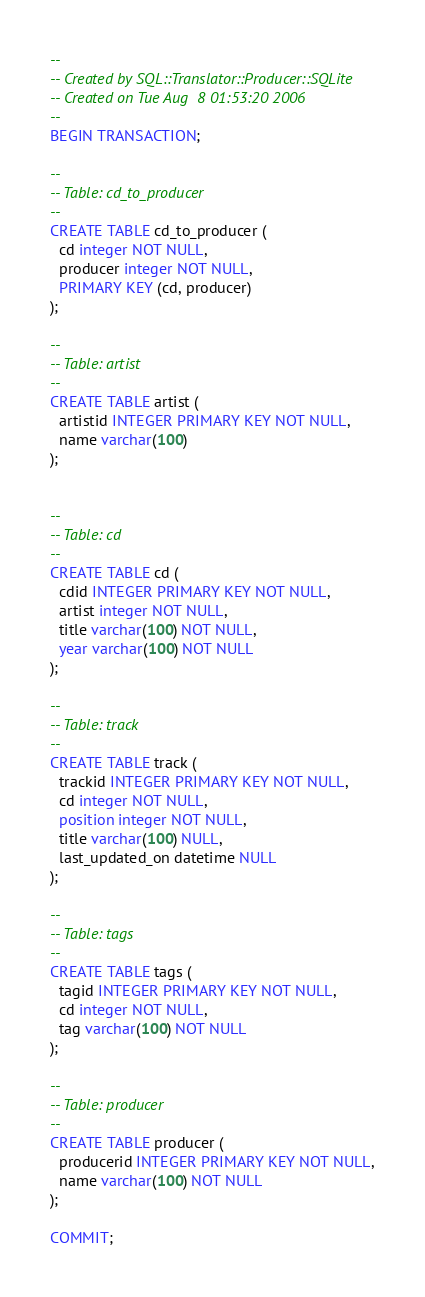<code> <loc_0><loc_0><loc_500><loc_500><_SQL_>-- 
-- Created by SQL::Translator::Producer::SQLite
-- Created on Tue Aug  8 01:53:20 2006
-- 
BEGIN TRANSACTION;

--
-- Table: cd_to_producer
--
CREATE TABLE cd_to_producer (
  cd integer NOT NULL,
  producer integer NOT NULL,
  PRIMARY KEY (cd, producer)
);

--
-- Table: artist
--
CREATE TABLE artist (
  artistid INTEGER PRIMARY KEY NOT NULL,
  name varchar(100)
);


--
-- Table: cd
--
CREATE TABLE cd (
  cdid INTEGER PRIMARY KEY NOT NULL,
  artist integer NOT NULL,
  title varchar(100) NOT NULL,
  year varchar(100) NOT NULL
);

--
-- Table: track
--
CREATE TABLE track (
  trackid INTEGER PRIMARY KEY NOT NULL,
  cd integer NOT NULL,
  position integer NOT NULL,
  title varchar(100) NULL,
  last_updated_on datetime NULL
);

--
-- Table: tags
--
CREATE TABLE tags (
  tagid INTEGER PRIMARY KEY NOT NULL,
  cd integer NOT NULL,
  tag varchar(100) NOT NULL
);

--
-- Table: producer
--
CREATE TABLE producer (
  producerid INTEGER PRIMARY KEY NOT NULL,
  name varchar(100) NOT NULL
);

COMMIT;
</code> 